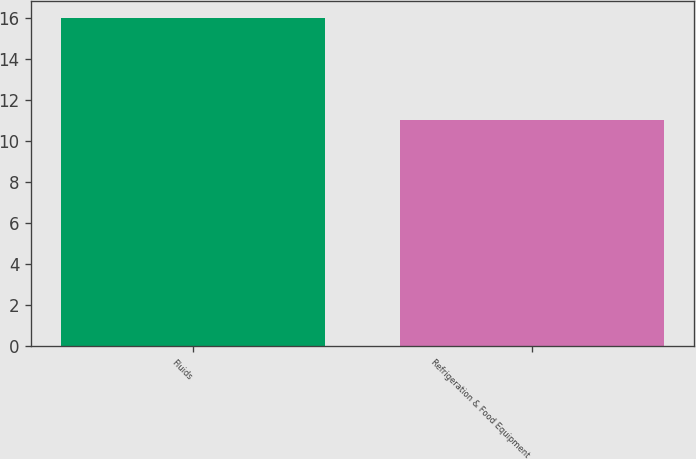Convert chart to OTSL. <chart><loc_0><loc_0><loc_500><loc_500><bar_chart><fcel>Fluids<fcel>Refrigeration & Food Equipment<nl><fcel>16<fcel>11<nl></chart> 